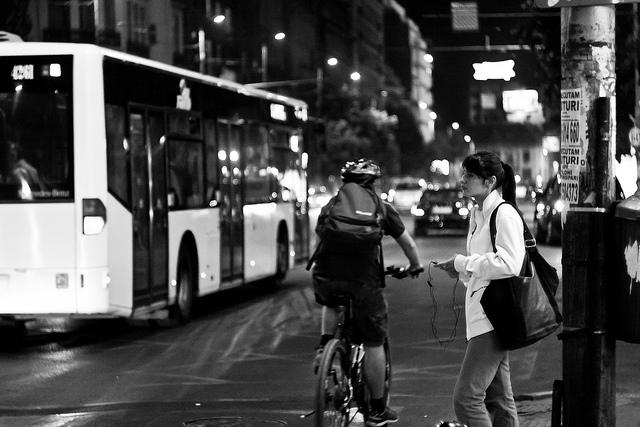What should the bus use to safely move in front of the bicyclist?

Choices:
A) wiper blades
B) sign
C) turning signals
D) motor turning signals 